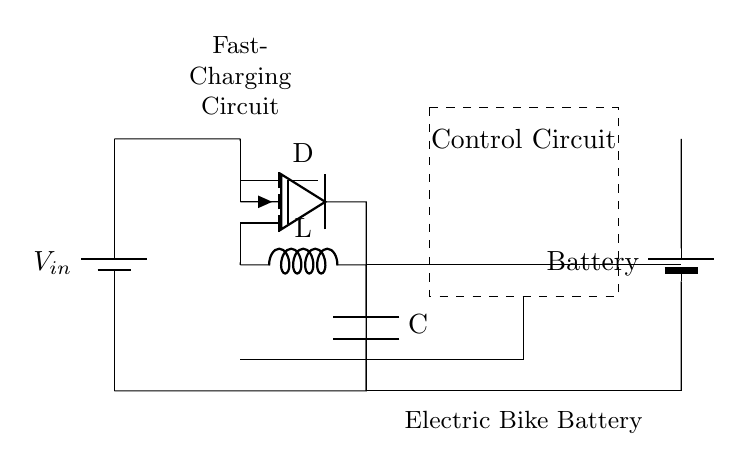What is the input voltage of the circuit? The input voltage can be identified from the label near the battery which indicates it as V_in. This is the voltage supplied to the circuit for charging.
Answer: V_in What type of converter is used in this circuit? The circuit explicitly shows a labeled component named "buck" which refers to a buck converter. This type of converter is used to step down the voltage.
Answer: Buck converter How many batteries are included in this circuit? There are two battery symbols depicted in the circuit diagram, one for the input voltage and one for the electric bike battery. This indicates the presence of two batteries.
Answer: Two What is the purpose of the control circuit? The control circuit is represented as a dashed rectangle and is responsible for managing the operation of the fast-charging circuit, ensuring proper charging conditions and monitoring.
Answer: Managing charging What is the function of the inductor in the circuit? The inductor, labeled as L, is utilized in the buck converter to store energy temporarily and help in regulating the output voltage to the battery. This functionality is essential in the energy conversion process.
Answer: Energy regulation What component regulates the current flow in the circuit? The diode is the component identified as D which allows current to flow in one direction and prevents reverse current. This is essential in protecting the battery from potential damage.
Answer: Diode What is the role of the capacitor in this circuit? The capacitor, labeled as C, is used to smooth out the output voltage and reduce ripple, thereby providing a stable voltage to the electric bike battery during the charging process.
Answer: Smoothing voltage 